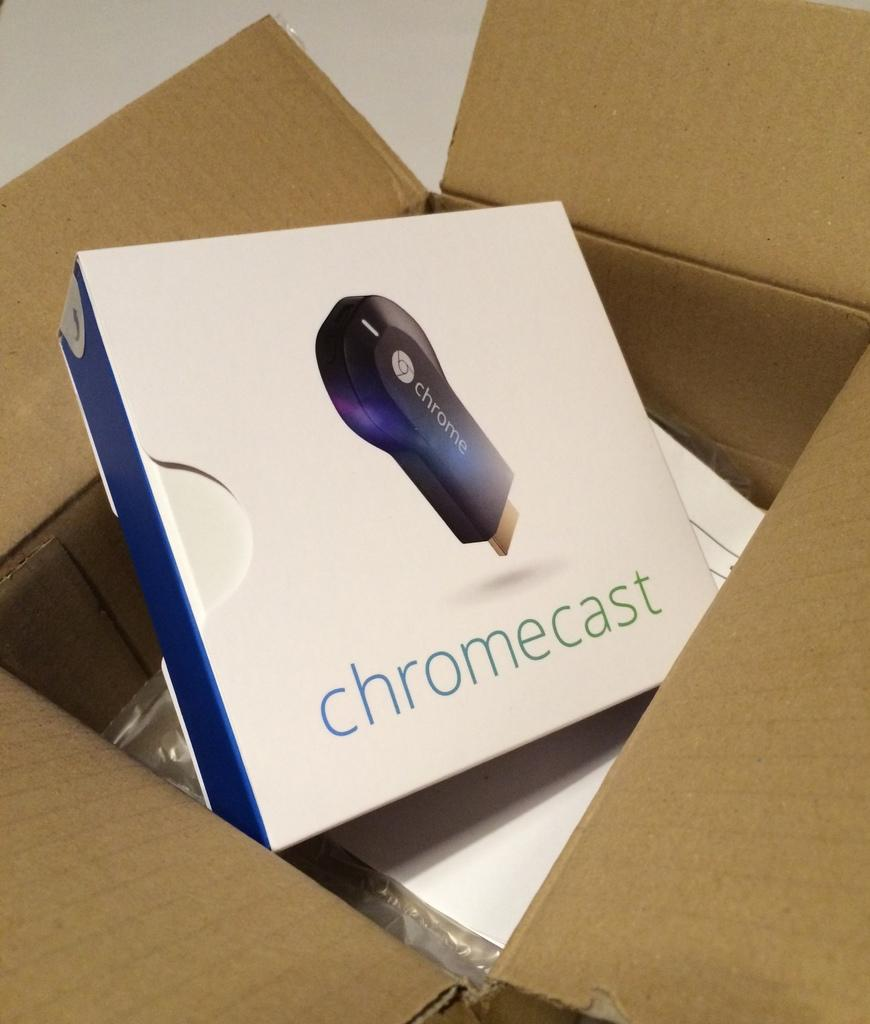<image>
Offer a succinct explanation of the picture presented. USB drive inside a white and blue box labeled Chromecast 